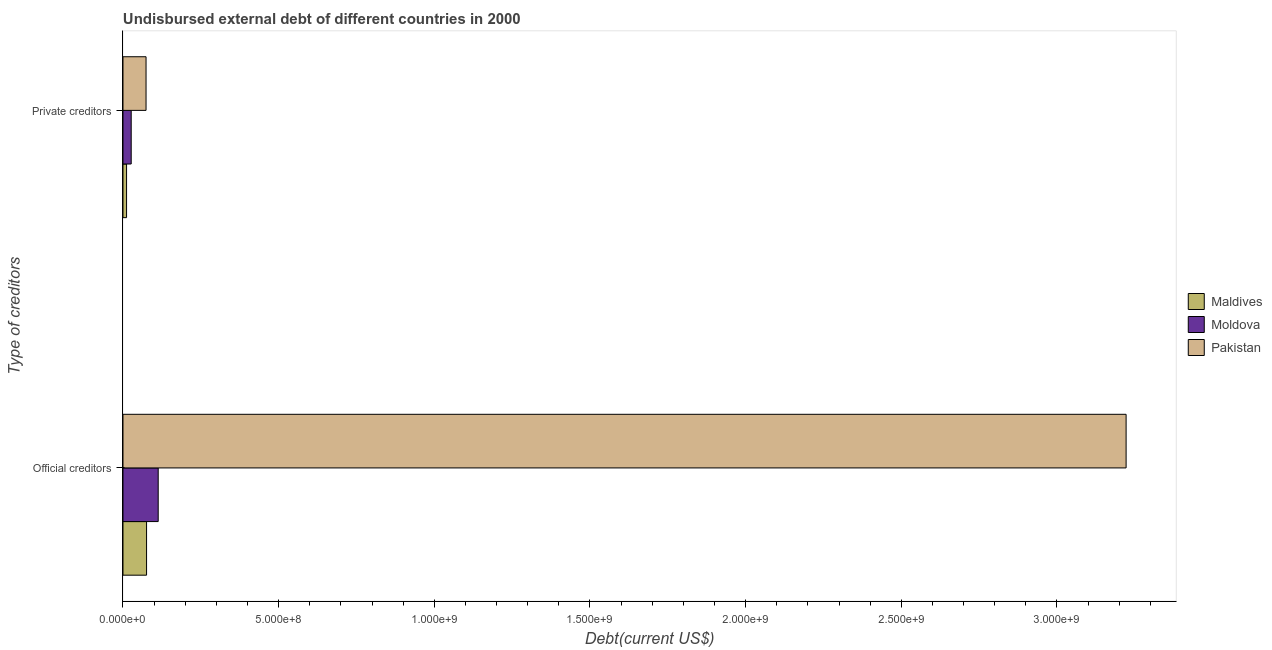How many different coloured bars are there?
Provide a short and direct response. 3. How many groups of bars are there?
Ensure brevity in your answer.  2. Are the number of bars per tick equal to the number of legend labels?
Your answer should be compact. Yes. Are the number of bars on each tick of the Y-axis equal?
Your answer should be compact. Yes. What is the label of the 2nd group of bars from the top?
Offer a very short reply. Official creditors. What is the undisbursed external debt of private creditors in Moldova?
Ensure brevity in your answer.  2.64e+07. Across all countries, what is the maximum undisbursed external debt of private creditors?
Provide a succinct answer. 7.41e+07. Across all countries, what is the minimum undisbursed external debt of official creditors?
Make the answer very short. 7.57e+07. In which country was the undisbursed external debt of private creditors minimum?
Offer a terse response. Maldives. What is the total undisbursed external debt of official creditors in the graph?
Ensure brevity in your answer.  3.41e+09. What is the difference between the undisbursed external debt of private creditors in Pakistan and that in Moldova?
Your answer should be very brief. 4.77e+07. What is the difference between the undisbursed external debt of private creditors in Moldova and the undisbursed external debt of official creditors in Pakistan?
Give a very brief answer. -3.20e+09. What is the average undisbursed external debt of official creditors per country?
Make the answer very short. 1.14e+09. What is the difference between the undisbursed external debt of private creditors and undisbursed external debt of official creditors in Pakistan?
Provide a succinct answer. -3.15e+09. In how many countries, is the undisbursed external debt of official creditors greater than 1400000000 US$?
Provide a short and direct response. 1. What is the ratio of the undisbursed external debt of private creditors in Moldova to that in Pakistan?
Offer a terse response. 0.36. What does the 1st bar from the bottom in Official creditors represents?
Offer a terse response. Maldives. How many bars are there?
Provide a short and direct response. 6. Are all the bars in the graph horizontal?
Make the answer very short. Yes. What is the difference between two consecutive major ticks on the X-axis?
Offer a very short reply. 5.00e+08. Does the graph contain any zero values?
Provide a succinct answer. No. Does the graph contain grids?
Ensure brevity in your answer.  No. Where does the legend appear in the graph?
Keep it short and to the point. Center right. What is the title of the graph?
Offer a terse response. Undisbursed external debt of different countries in 2000. What is the label or title of the X-axis?
Provide a succinct answer. Debt(current US$). What is the label or title of the Y-axis?
Offer a terse response. Type of creditors. What is the Debt(current US$) in Maldives in Official creditors?
Provide a short and direct response. 7.57e+07. What is the Debt(current US$) of Moldova in Official creditors?
Provide a short and direct response. 1.13e+08. What is the Debt(current US$) in Pakistan in Official creditors?
Make the answer very short. 3.22e+09. What is the Debt(current US$) of Maldives in Private creditors?
Provide a succinct answer. 1.15e+07. What is the Debt(current US$) of Moldova in Private creditors?
Offer a terse response. 2.64e+07. What is the Debt(current US$) of Pakistan in Private creditors?
Offer a very short reply. 7.41e+07. Across all Type of creditors, what is the maximum Debt(current US$) of Maldives?
Keep it short and to the point. 7.57e+07. Across all Type of creditors, what is the maximum Debt(current US$) in Moldova?
Your answer should be very brief. 1.13e+08. Across all Type of creditors, what is the maximum Debt(current US$) of Pakistan?
Give a very brief answer. 3.22e+09. Across all Type of creditors, what is the minimum Debt(current US$) of Maldives?
Offer a terse response. 1.15e+07. Across all Type of creditors, what is the minimum Debt(current US$) in Moldova?
Make the answer very short. 2.64e+07. Across all Type of creditors, what is the minimum Debt(current US$) in Pakistan?
Your answer should be very brief. 7.41e+07. What is the total Debt(current US$) in Maldives in the graph?
Give a very brief answer. 8.73e+07. What is the total Debt(current US$) of Moldova in the graph?
Provide a short and direct response. 1.40e+08. What is the total Debt(current US$) of Pakistan in the graph?
Offer a terse response. 3.30e+09. What is the difference between the Debt(current US$) in Maldives in Official creditors and that in Private creditors?
Give a very brief answer. 6.42e+07. What is the difference between the Debt(current US$) in Moldova in Official creditors and that in Private creditors?
Offer a very short reply. 8.67e+07. What is the difference between the Debt(current US$) in Pakistan in Official creditors and that in Private creditors?
Keep it short and to the point. 3.15e+09. What is the difference between the Debt(current US$) in Maldives in Official creditors and the Debt(current US$) in Moldova in Private creditors?
Give a very brief answer. 4.93e+07. What is the difference between the Debt(current US$) of Maldives in Official creditors and the Debt(current US$) of Pakistan in Private creditors?
Your answer should be compact. 1.66e+06. What is the difference between the Debt(current US$) of Moldova in Official creditors and the Debt(current US$) of Pakistan in Private creditors?
Make the answer very short. 3.91e+07. What is the average Debt(current US$) in Maldives per Type of creditors?
Offer a terse response. 4.36e+07. What is the average Debt(current US$) of Moldova per Type of creditors?
Make the answer very short. 6.98e+07. What is the average Debt(current US$) in Pakistan per Type of creditors?
Your answer should be very brief. 1.65e+09. What is the difference between the Debt(current US$) of Maldives and Debt(current US$) of Moldova in Official creditors?
Make the answer very short. -3.74e+07. What is the difference between the Debt(current US$) of Maldives and Debt(current US$) of Pakistan in Official creditors?
Ensure brevity in your answer.  -3.15e+09. What is the difference between the Debt(current US$) of Moldova and Debt(current US$) of Pakistan in Official creditors?
Your response must be concise. -3.11e+09. What is the difference between the Debt(current US$) in Maldives and Debt(current US$) in Moldova in Private creditors?
Keep it short and to the point. -1.49e+07. What is the difference between the Debt(current US$) of Maldives and Debt(current US$) of Pakistan in Private creditors?
Provide a short and direct response. -6.26e+07. What is the difference between the Debt(current US$) in Moldova and Debt(current US$) in Pakistan in Private creditors?
Keep it short and to the point. -4.77e+07. What is the ratio of the Debt(current US$) in Maldives in Official creditors to that in Private creditors?
Offer a terse response. 6.58. What is the ratio of the Debt(current US$) in Moldova in Official creditors to that in Private creditors?
Make the answer very short. 4.28. What is the ratio of the Debt(current US$) of Pakistan in Official creditors to that in Private creditors?
Your answer should be compact. 43.5. What is the difference between the highest and the second highest Debt(current US$) of Maldives?
Your answer should be very brief. 6.42e+07. What is the difference between the highest and the second highest Debt(current US$) of Moldova?
Your answer should be compact. 8.67e+07. What is the difference between the highest and the second highest Debt(current US$) of Pakistan?
Keep it short and to the point. 3.15e+09. What is the difference between the highest and the lowest Debt(current US$) of Maldives?
Your response must be concise. 6.42e+07. What is the difference between the highest and the lowest Debt(current US$) of Moldova?
Keep it short and to the point. 8.67e+07. What is the difference between the highest and the lowest Debt(current US$) in Pakistan?
Your answer should be very brief. 3.15e+09. 